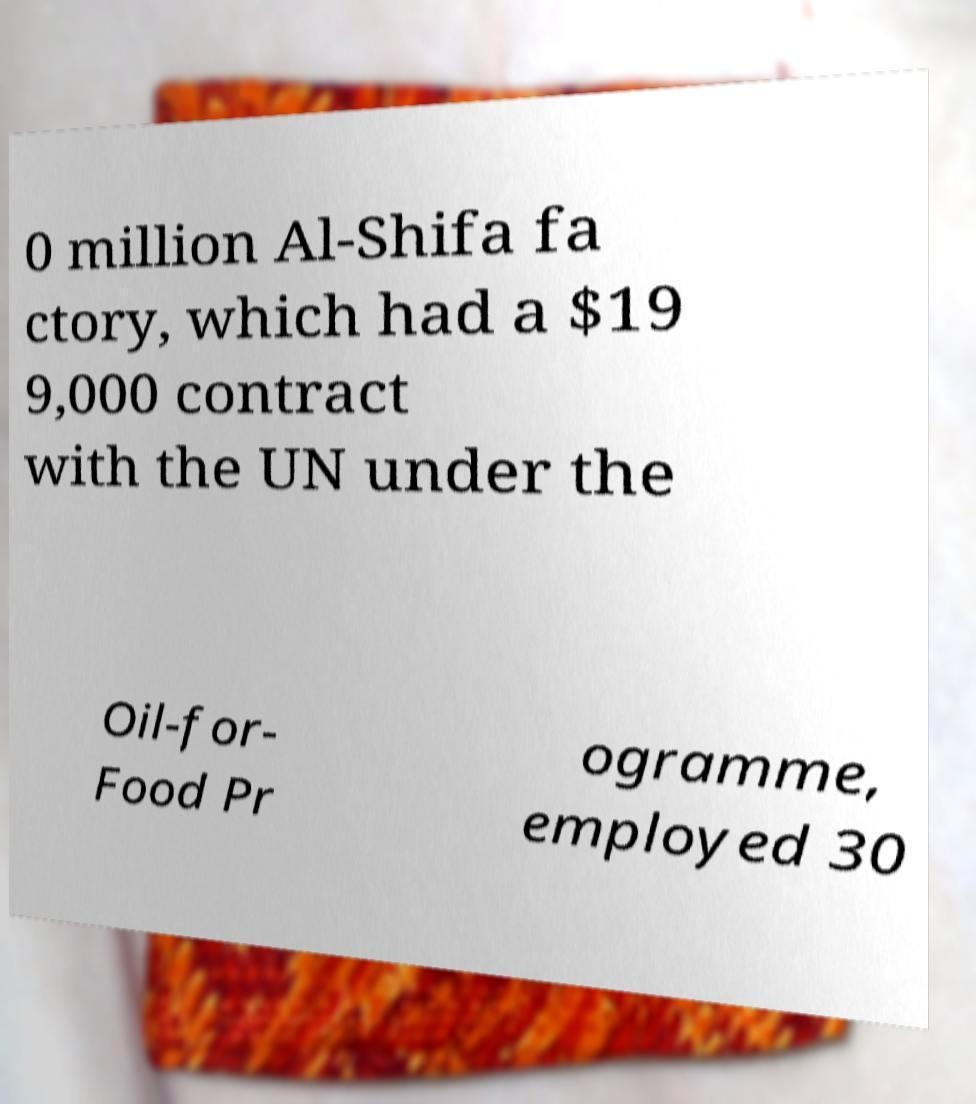Could you assist in decoding the text presented in this image and type it out clearly? 0 million Al-Shifa fa ctory, which had a $19 9,000 contract with the UN under the Oil-for- Food Pr ogramme, employed 30 